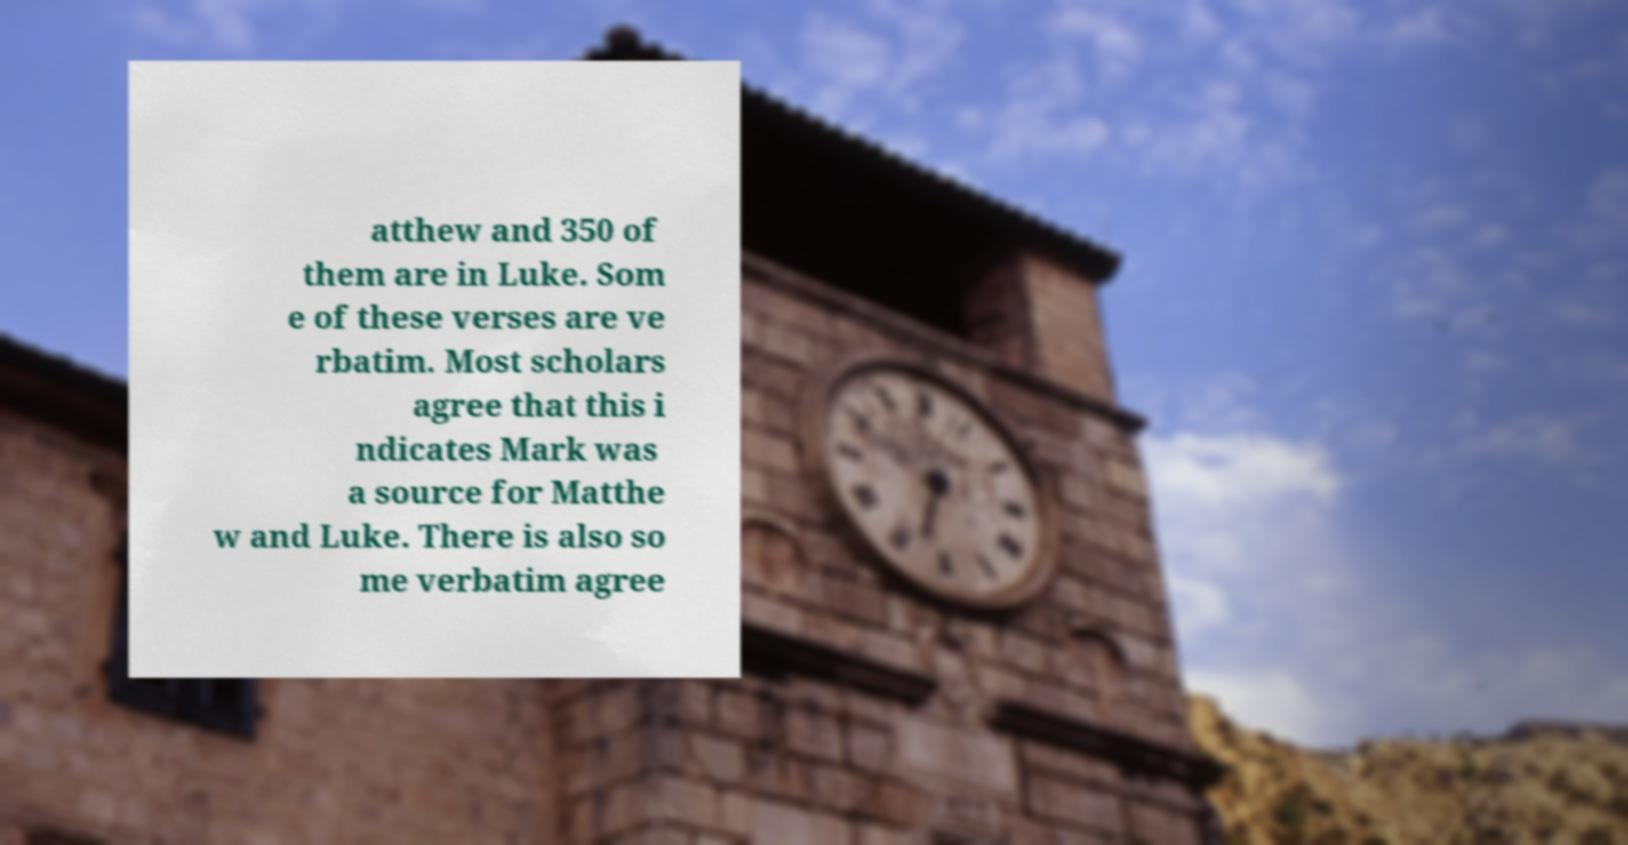Could you assist in decoding the text presented in this image and type it out clearly? atthew and 350 of them are in Luke. Som e of these verses are ve rbatim. Most scholars agree that this i ndicates Mark was a source for Matthe w and Luke. There is also so me verbatim agree 